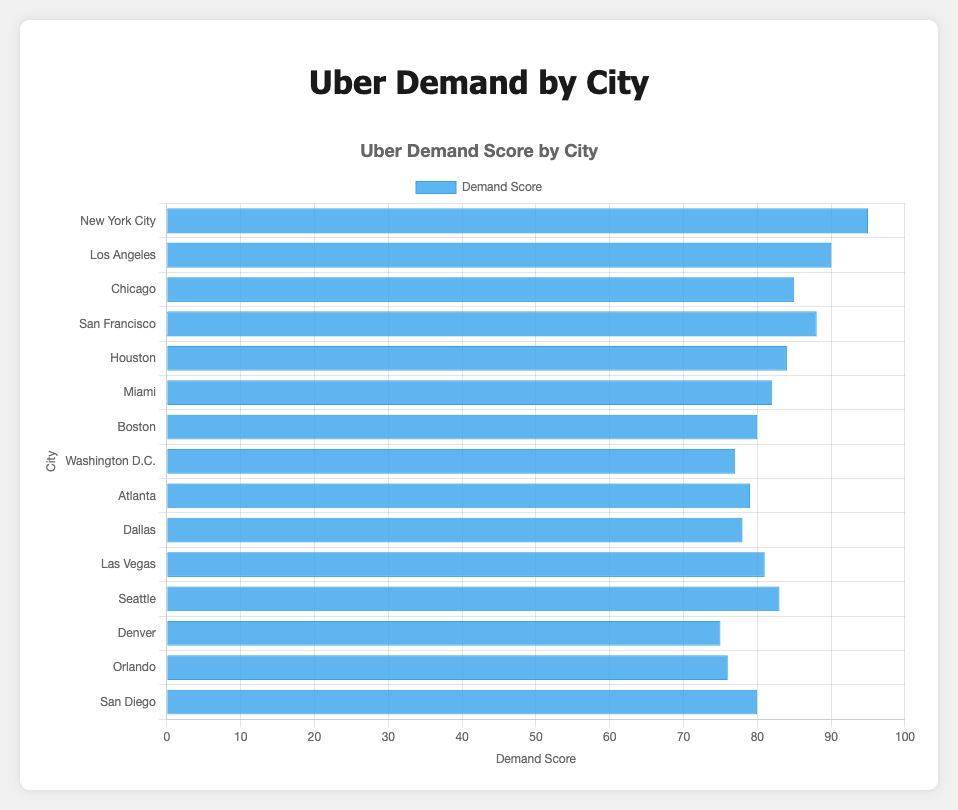Which city has the highest Uber demand score? By referring to the height of the bar in the horizontal bar chart, the city with the highest demand score (the longest bar reaching closest to 100) is identified.
Answer: New York City Which city has the lowest average wait time? By looking at the tooltip information provided when hovering over the bars, the city with the shortest average wait time can be identified.
Answer: Las Vegas What is the difference in demand scores between New York City and Los Angeles? New York City has a demand score of 95, and Los Angeles has a demand score of 90. The difference can be calculated by subtracting the demand score of Los Angeles from that of New York City. 95 - 90 = 5.
Answer: 5 Which city has a higher average wait time, Seattle or Boston? By looking at the tooltip information for Seattle and Boston, we can compare the average wait times. Boston has an average wait time of 6.3 minutes, and Seattle has 6.6 minutes.
Answer: Seattle What is the average demand score of New York City, Los Angeles, and Chicago combined? Adding the demand scores of New York City (95), Los Angeles (90), and Chicago (85) and then dividing by 3 gives the average: (95 + 90 + 85) / 3 = 270 / 3 = 90.
Answer: 90 Which city has a lower demand score but a longer average wait time than Houston? Houston has a demand score of 84 and an average wait time of 7.0 minutes. By checking cities with a lower demand score but a longer average wait time, Los Angeles with a demand score of 90 and a wait time of 7.2 minutes, Dallas with a score of 78 and wait time of 7.1 minutes, Dallas fits the criteria better.
Answer: Dallas How many cities have an average wait time less than 6 minutes? Cities with average wait times less than 6 minutes are identified as follows: Chicago (5.8 minutes), Washington D.C. (5.5 minutes), Las Vegas (5.2 minutes), Denver (5.9 minutes). The count is 4.
Answer: 4 Which city has the highest demand score with a wait time over 7 minutes? By checking the cities with an average wait time over 7 minutes (Los Angeles: 7.2, Houston: 7.0, Dallas: 7.1), then comparing their demand scores, Los Angeles has the highest demand score of 90.
Answer: Los Angeles What is the combined demand score of cities with an average wait time below 6 minutes? The cities with wait times below 6 minutes are Chicago (85), Washington D.C. (77), Las Vegas (81), and Denver (75). Summing their demand scores: 85 + 77 + 81 + 75 = 318.
Answer: 318 